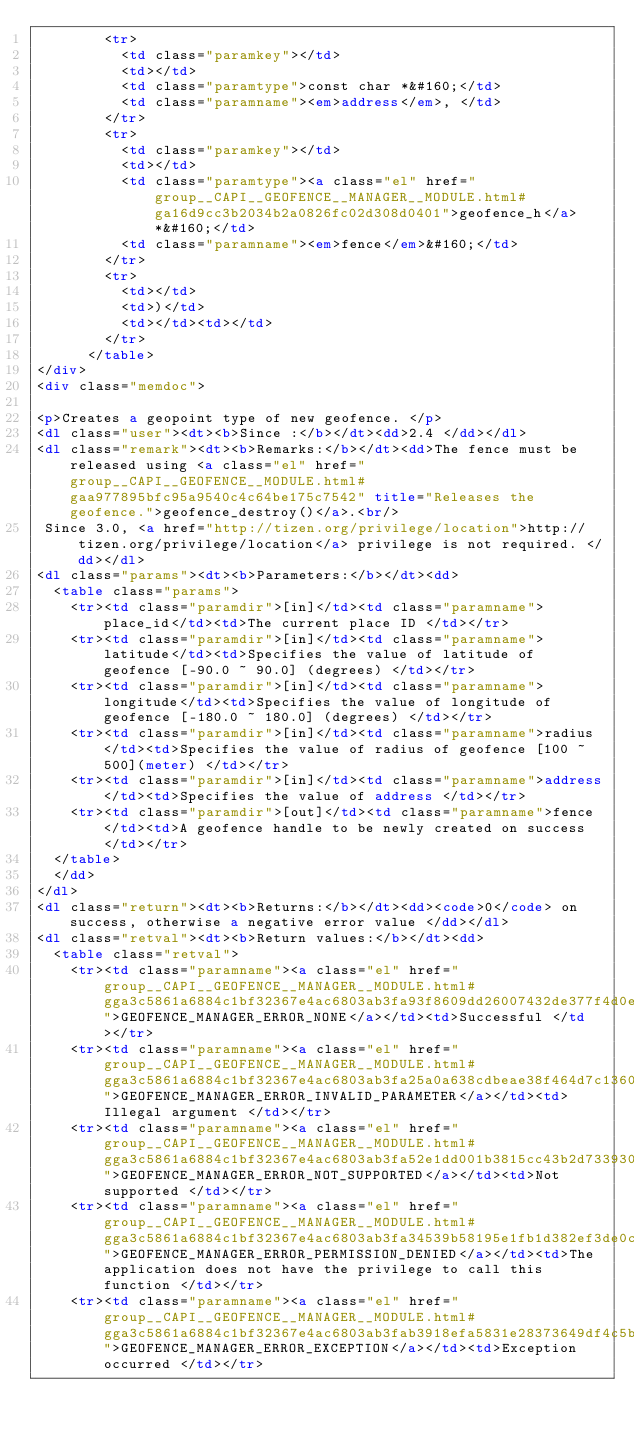<code> <loc_0><loc_0><loc_500><loc_500><_HTML_>        <tr>
          <td class="paramkey"></td>
          <td></td>
          <td class="paramtype">const char *&#160;</td>
          <td class="paramname"><em>address</em>, </td>
        </tr>
        <tr>
          <td class="paramkey"></td>
          <td></td>
          <td class="paramtype"><a class="el" href="group__CAPI__GEOFENCE__MANAGER__MODULE.html#ga16d9cc3b2034b2a0826fc02d308d0401">geofence_h</a> *&#160;</td>
          <td class="paramname"><em>fence</em>&#160;</td>
        </tr>
        <tr>
          <td></td>
          <td>)</td>
          <td></td><td></td>
        </tr>
      </table>
</div>
<div class="memdoc">

<p>Creates a geopoint type of new geofence. </p>
<dl class="user"><dt><b>Since :</b></dt><dd>2.4 </dd></dl>
<dl class="remark"><dt><b>Remarks:</b></dt><dd>The fence must be released using <a class="el" href="group__CAPI__GEOFENCE__MODULE.html#gaa977895bfc95a9540c4c64be175c7542" title="Releases the geofence.">geofence_destroy()</a>.<br/>
 Since 3.0, <a href="http://tizen.org/privilege/location">http://tizen.org/privilege/location</a> privilege is not required. </dd></dl>
<dl class="params"><dt><b>Parameters:</b></dt><dd>
  <table class="params">
    <tr><td class="paramdir">[in]</td><td class="paramname">place_id</td><td>The current place ID </td></tr>
    <tr><td class="paramdir">[in]</td><td class="paramname">latitude</td><td>Specifies the value of latitude of geofence [-90.0 ~ 90.0] (degrees) </td></tr>
    <tr><td class="paramdir">[in]</td><td class="paramname">longitude</td><td>Specifies the value of longitude of geofence [-180.0 ~ 180.0] (degrees) </td></tr>
    <tr><td class="paramdir">[in]</td><td class="paramname">radius</td><td>Specifies the value of radius of geofence [100 ~ 500](meter) </td></tr>
    <tr><td class="paramdir">[in]</td><td class="paramname">address</td><td>Specifies the value of address </td></tr>
    <tr><td class="paramdir">[out]</td><td class="paramname">fence</td><td>A geofence handle to be newly created on success </td></tr>
  </table>
  </dd>
</dl>
<dl class="return"><dt><b>Returns:</b></dt><dd><code>0</code> on success, otherwise a negative error value </dd></dl>
<dl class="retval"><dt><b>Return values:</b></dt><dd>
  <table class="retval">
    <tr><td class="paramname"><a class="el" href="group__CAPI__GEOFENCE__MANAGER__MODULE.html#gga3c5861a6884c1bf32367e4ac6803ab3fa93f8609dd26007432de377f4d0e3ee34">GEOFENCE_MANAGER_ERROR_NONE</a></td><td>Successful </td></tr>
    <tr><td class="paramname"><a class="el" href="group__CAPI__GEOFENCE__MANAGER__MODULE.html#gga3c5861a6884c1bf32367e4ac6803ab3fa25a0a638cdbeae38f464d7c1360e9fa8">GEOFENCE_MANAGER_ERROR_INVALID_PARAMETER</a></td><td>Illegal argument </td></tr>
    <tr><td class="paramname"><a class="el" href="group__CAPI__GEOFENCE__MANAGER__MODULE.html#gga3c5861a6884c1bf32367e4ac6803ab3fa52e1dd001b3815cc43b2d7339305d3dc">GEOFENCE_MANAGER_ERROR_NOT_SUPPORTED</a></td><td>Not supported </td></tr>
    <tr><td class="paramname"><a class="el" href="group__CAPI__GEOFENCE__MANAGER__MODULE.html#gga3c5861a6884c1bf32367e4ac6803ab3fa34539b58195e1fb1d382ef3de0c63ed8">GEOFENCE_MANAGER_ERROR_PERMISSION_DENIED</a></td><td>The application does not have the privilege to call this function </td></tr>
    <tr><td class="paramname"><a class="el" href="group__CAPI__GEOFENCE__MANAGER__MODULE.html#gga3c5861a6884c1bf32367e4ac6803ab3fab3918efa5831e28373649df4c5bfeb15">GEOFENCE_MANAGER_ERROR_EXCEPTION</a></td><td>Exception occurred </td></tr></code> 